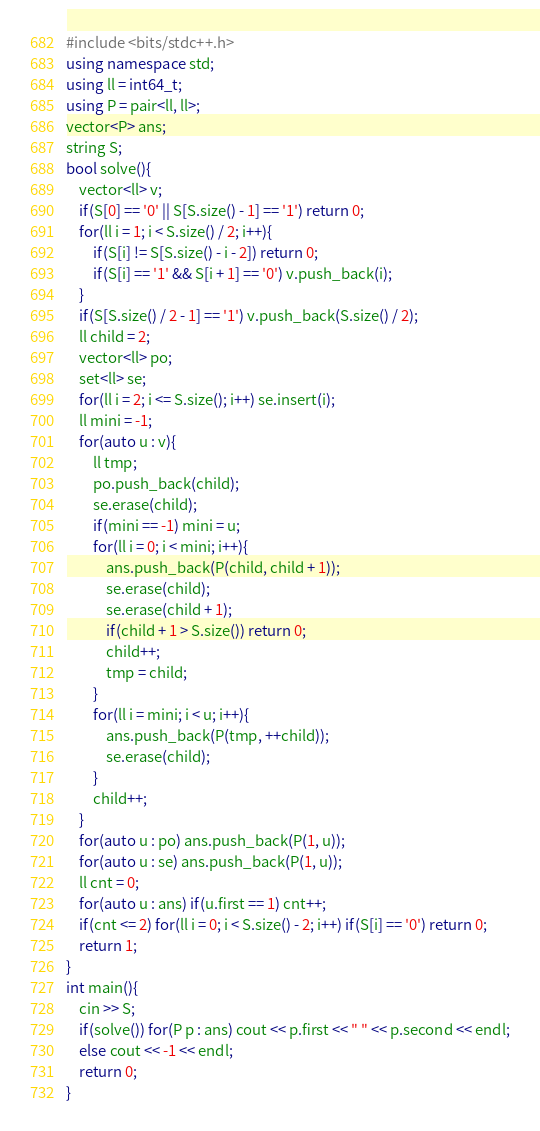<code> <loc_0><loc_0><loc_500><loc_500><_C++_>#include <bits/stdc++.h>
using namespace std;
using ll = int64_t;
using P = pair<ll, ll>;
vector<P> ans;
string S;
bool solve(){
    vector<ll> v;
    if(S[0] == '0' || S[S.size() - 1] == '1') return 0;
    for(ll i = 1; i < S.size() / 2; i++){
        if(S[i] != S[S.size() - i - 2]) return 0;
        if(S[i] == '1' && S[i + 1] == '0') v.push_back(i);
    }
    if(S[S.size() / 2 - 1] == '1') v.push_back(S.size() / 2);
    ll child = 2;
    vector<ll> po;
    set<ll> se;
    for(ll i = 2; i <= S.size(); i++) se.insert(i);
    ll mini = -1;
    for(auto u : v){
        ll tmp;
        po.push_back(child);
        se.erase(child);
        if(mini == -1) mini = u;
        for(ll i = 0; i < mini; i++){
            ans.push_back(P(child, child + 1));
            se.erase(child);
            se.erase(child + 1);
            if(child + 1 > S.size()) return 0;
            child++;
            tmp = child;
        }
        for(ll i = mini; i < u; i++){
            ans.push_back(P(tmp, ++child));
            se.erase(child);
        }
        child++;
    }
    for(auto u : po) ans.push_back(P(1, u));
    for(auto u : se) ans.push_back(P(1, u));
    ll cnt = 0;
    for(auto u : ans) if(u.first == 1) cnt++;
    if(cnt <= 2) for(ll i = 0; i < S.size() - 2; i++) if(S[i] == '0') return 0;
    return 1;
}
int main(){
    cin >> S;
    if(solve()) for(P p : ans) cout << p.first << " " << p.second << endl;
    else cout << -1 << endl;
    return 0;
}
</code> 